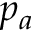<formula> <loc_0><loc_0><loc_500><loc_500>p _ { a }</formula> 